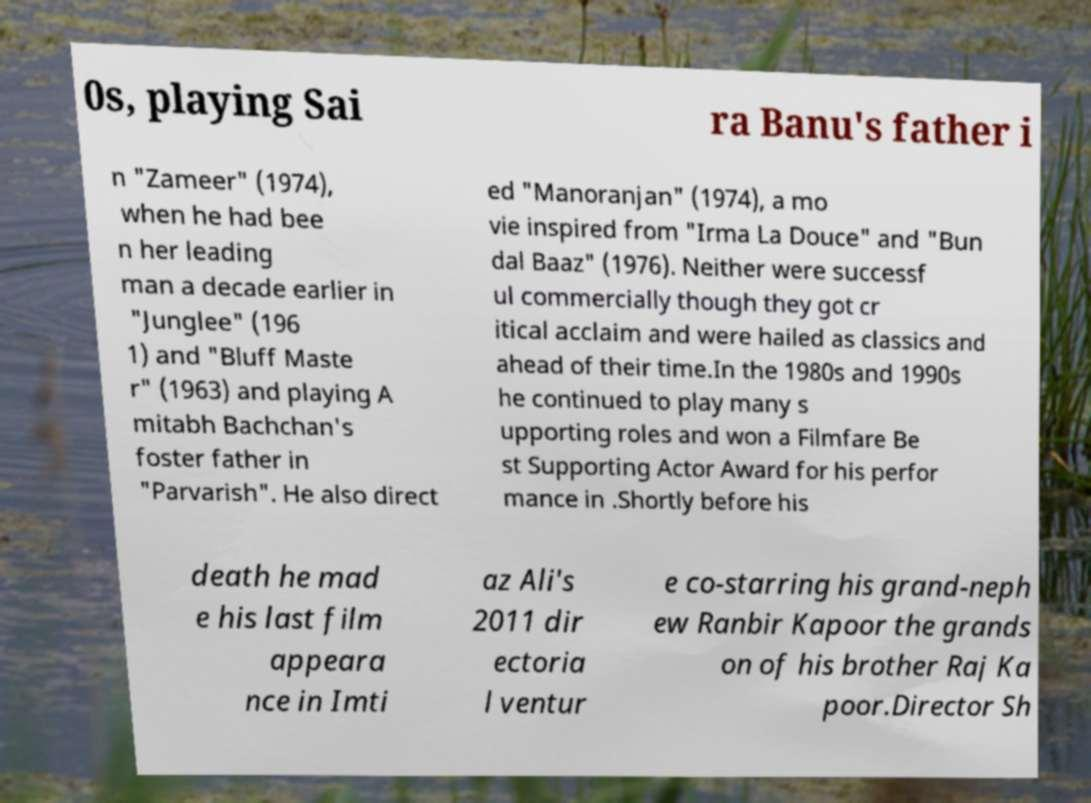Please read and relay the text visible in this image. What does it say? 0s, playing Sai ra Banu's father i n "Zameer" (1974), when he had bee n her leading man a decade earlier in "Junglee" (196 1) and "Bluff Maste r" (1963) and playing A mitabh Bachchan's foster father in "Parvarish". He also direct ed "Manoranjan" (1974), a mo vie inspired from "Irma La Douce" and "Bun dal Baaz" (1976). Neither were successf ul commercially though they got cr itical acclaim and were hailed as classics and ahead of their time.In the 1980s and 1990s he continued to play many s upporting roles and won a Filmfare Be st Supporting Actor Award for his perfor mance in .Shortly before his death he mad e his last film appeara nce in Imti az Ali's 2011 dir ectoria l ventur e co-starring his grand-neph ew Ranbir Kapoor the grands on of his brother Raj Ka poor.Director Sh 